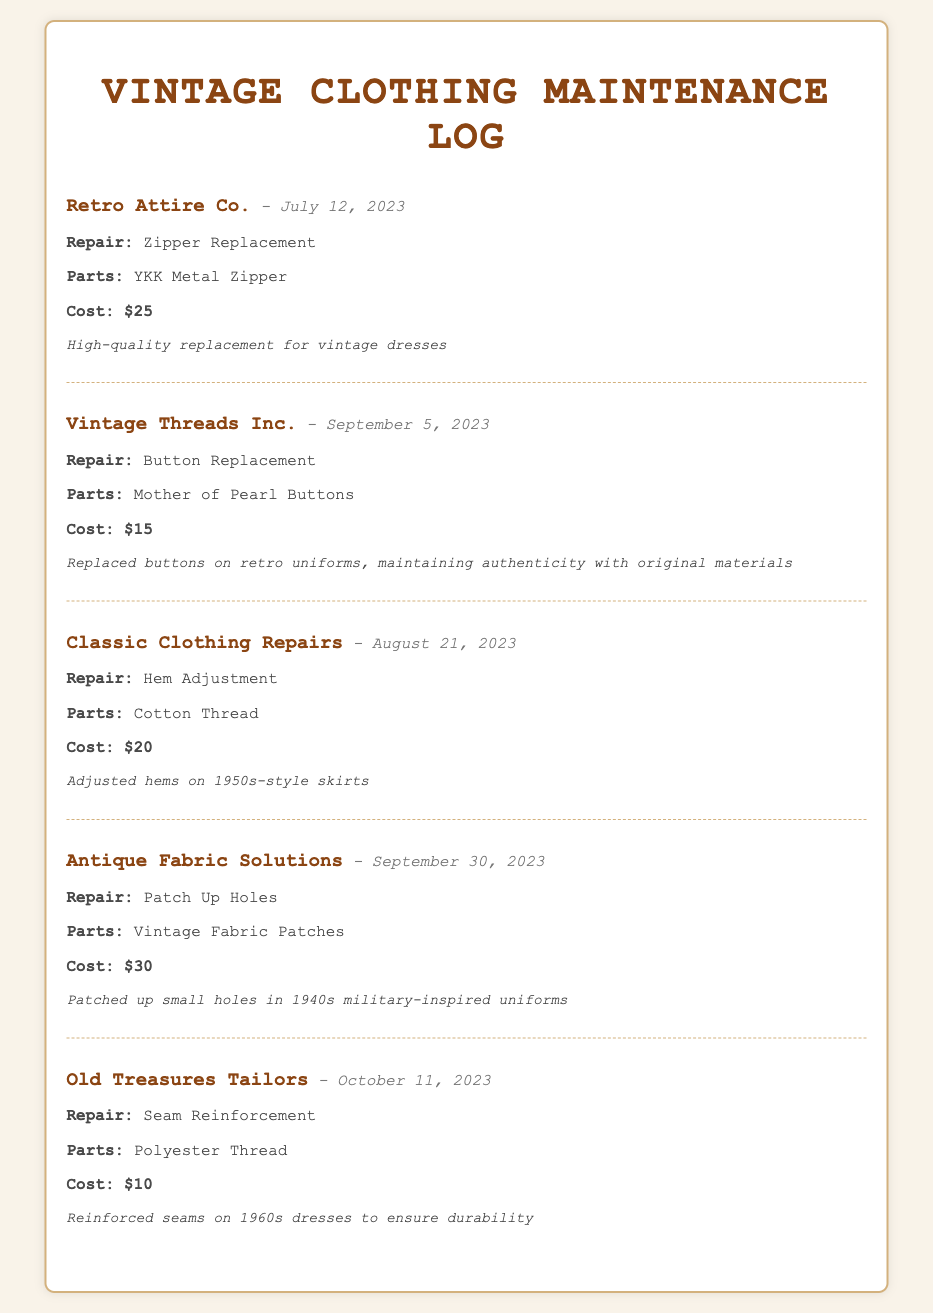What is the name of the first supplier? The first supplier listed in the document is "Retro Attire Co."
Answer: Retro Attire Co What was the cost of the button replacement? The cost for the button replacement with Vintage Threads Inc. is detailed as $15.
Answer: $15 When was the seam reinforcement performed? The seam reinforcement was done on October 11, 2023, as specified in the log entry.
Answer: October 11, 2023 What parts were used for the hem adjustment? The log entry for the hem adjustment notes the use of "Cotton Thread" as the part replaced.
Answer: Cotton Thread Which supplier provided the service for patching up holes? The supplier that provided the service for patching up holes is "Antique Fabric Solutions."
Answer: Antique Fabric Solutions What type of repair was performed by Classic Clothing Repairs? The type of repair performed by Classic Clothing Repairs is a "Hem Adjustment."
Answer: Hem Adjustment How much did the zipper replacement cost? The cost of the zipper replacement is recorded as $25 in the document.
Answer: $25 What materials were used for the button replacement repairs? The document specifies that "Mother of Pearl Buttons" were used for the button replacement repairs.
Answer: Mother of Pearl Buttons How many repair entries are listed in the document? The document lists a total of five repair entries, noting each interaction separately.
Answer: Five 